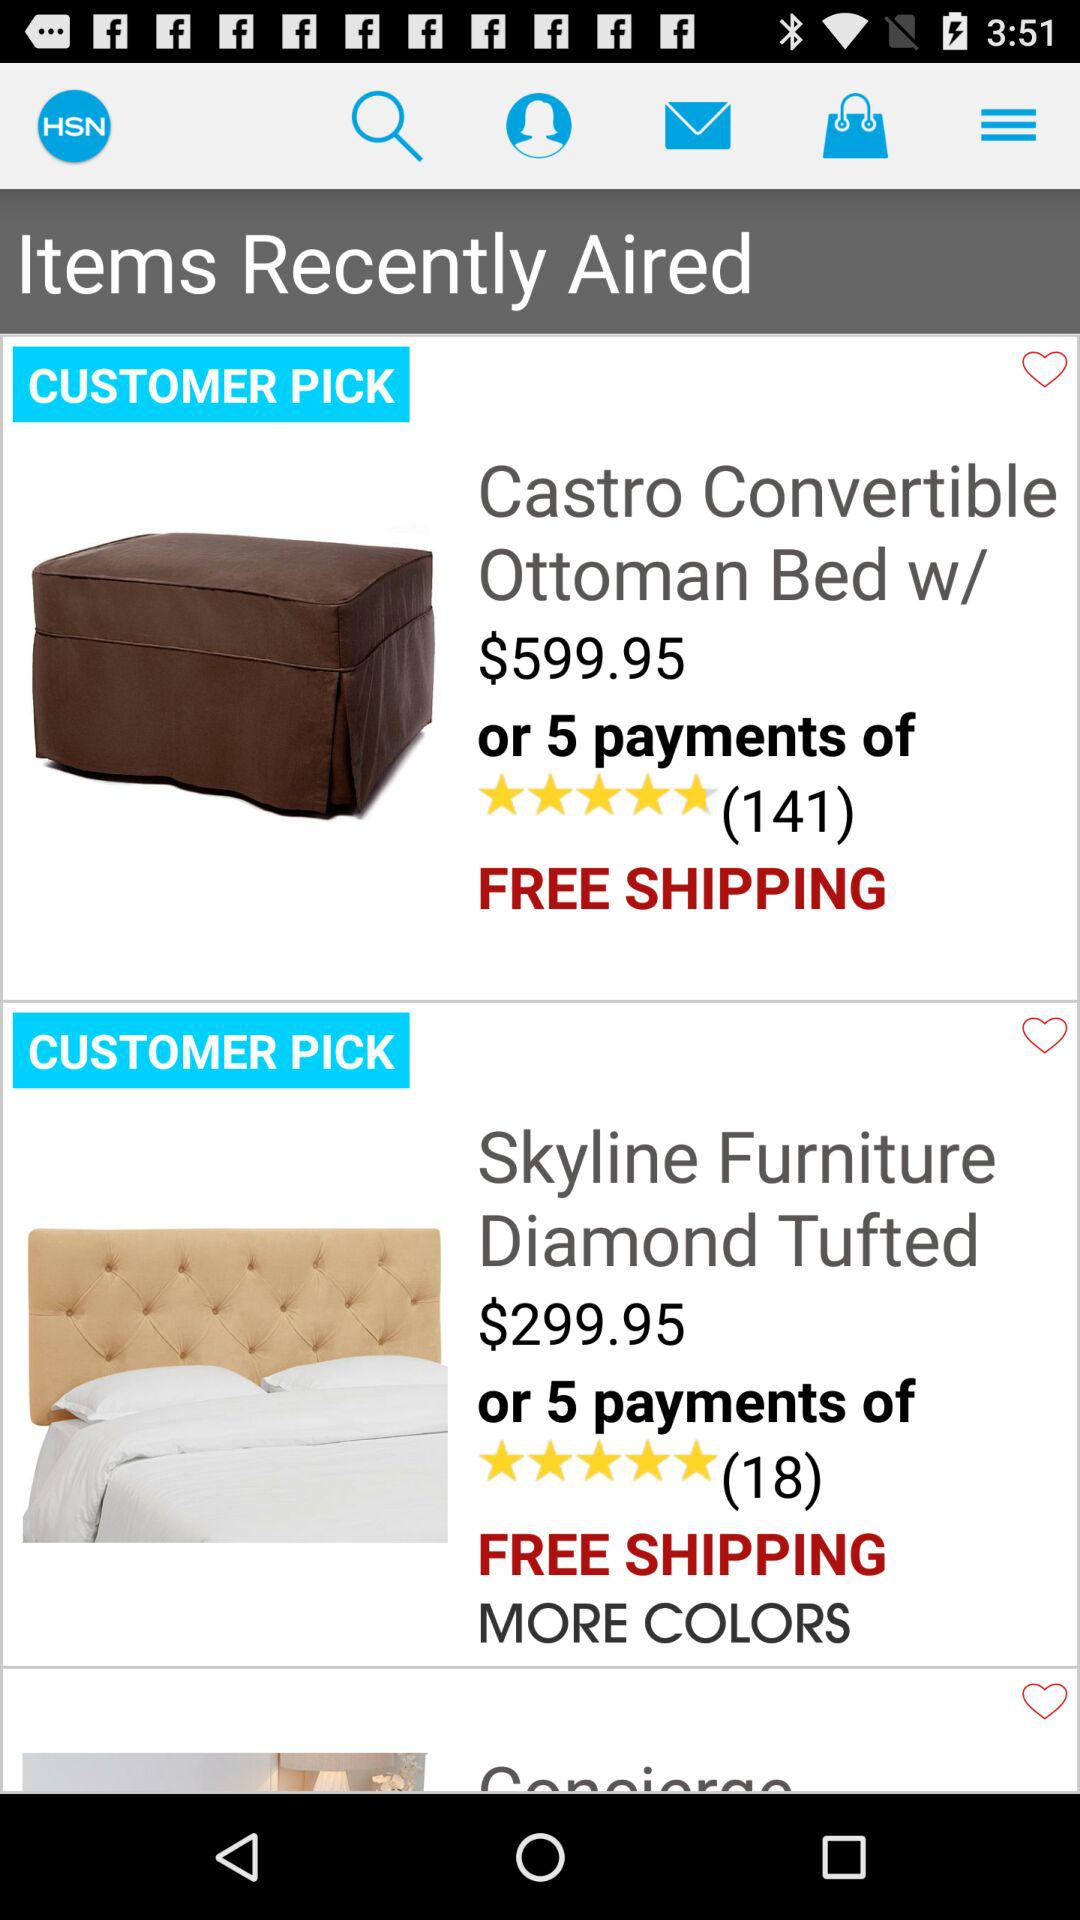What is the rating of "Skyline Furniture Diamond Tufted"? The rating of "Skyline Furniture Diamond Tufted" is 5 stars. 